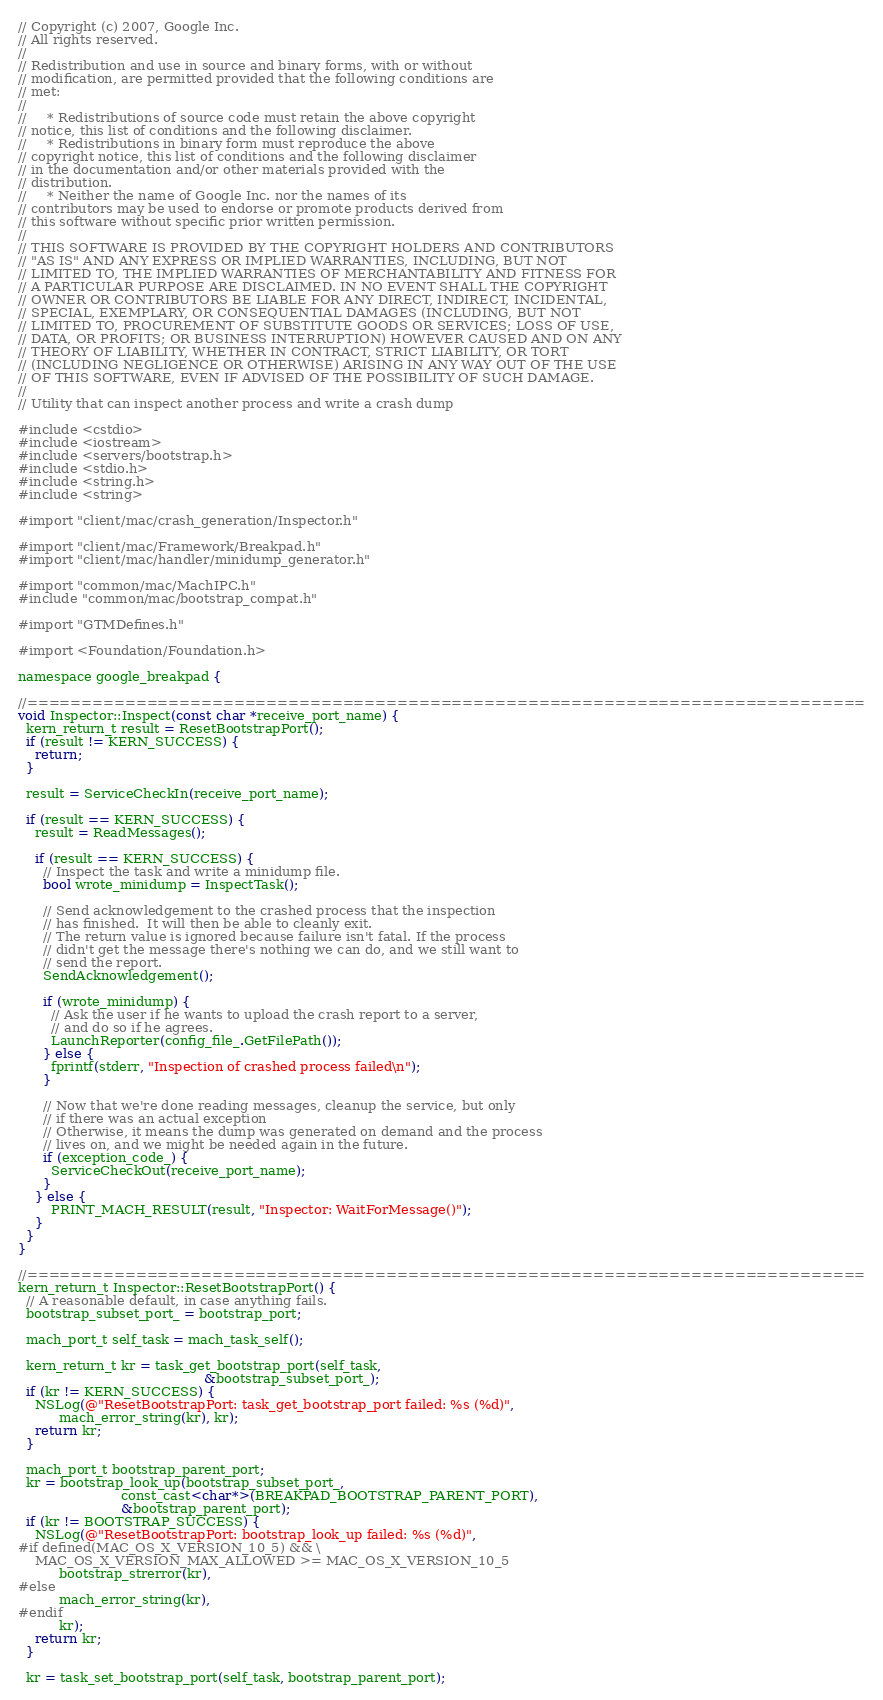<code> <loc_0><loc_0><loc_500><loc_500><_ObjectiveC_>// Copyright (c) 2007, Google Inc.
// All rights reserved.
//
// Redistribution and use in source and binary forms, with or without
// modification, are permitted provided that the following conditions are
// met:
//
//     * Redistributions of source code must retain the above copyright
// notice, this list of conditions and the following disclaimer.
//     * Redistributions in binary form must reproduce the above
// copyright notice, this list of conditions and the following disclaimer
// in the documentation and/or other materials provided with the
// distribution.
//     * Neither the name of Google Inc. nor the names of its
// contributors may be used to endorse or promote products derived from
// this software without specific prior written permission.
//
// THIS SOFTWARE IS PROVIDED BY THE COPYRIGHT HOLDERS AND CONTRIBUTORS
// "AS IS" AND ANY EXPRESS OR IMPLIED WARRANTIES, INCLUDING, BUT NOT
// LIMITED TO, THE IMPLIED WARRANTIES OF MERCHANTABILITY AND FITNESS FOR
// A PARTICULAR PURPOSE ARE DISCLAIMED. IN NO EVENT SHALL THE COPYRIGHT
// OWNER OR CONTRIBUTORS BE LIABLE FOR ANY DIRECT, INDIRECT, INCIDENTAL,
// SPECIAL, EXEMPLARY, OR CONSEQUENTIAL DAMAGES (INCLUDING, BUT NOT
// LIMITED TO, PROCUREMENT OF SUBSTITUTE GOODS OR SERVICES; LOSS OF USE,
// DATA, OR PROFITS; OR BUSINESS INTERRUPTION) HOWEVER CAUSED AND ON ANY
// THEORY OF LIABILITY, WHETHER IN CONTRACT, STRICT LIABILITY, OR TORT
// (INCLUDING NEGLIGENCE OR OTHERWISE) ARISING IN ANY WAY OUT OF THE USE
// OF THIS SOFTWARE, EVEN IF ADVISED OF THE POSSIBILITY OF SUCH DAMAGE.
//
// Utility that can inspect another process and write a crash dump

#include <cstdio>
#include <iostream>
#include <servers/bootstrap.h>
#include <stdio.h>
#include <string.h>
#include <string>

#import "client/mac/crash_generation/Inspector.h"

#import "client/mac/Framework/Breakpad.h"
#import "client/mac/handler/minidump_generator.h"

#import "common/mac/MachIPC.h"
#include "common/mac/bootstrap_compat.h"

#import "GTMDefines.h"

#import <Foundation/Foundation.h>

namespace google_breakpad {

//=============================================================================
void Inspector::Inspect(const char *receive_port_name) {
  kern_return_t result = ResetBootstrapPort();
  if (result != KERN_SUCCESS) {
    return;
  }

  result = ServiceCheckIn(receive_port_name);

  if (result == KERN_SUCCESS) {
    result = ReadMessages();

    if (result == KERN_SUCCESS) {
      // Inspect the task and write a minidump file.
      bool wrote_minidump = InspectTask();

      // Send acknowledgement to the crashed process that the inspection
      // has finished.  It will then be able to cleanly exit.
      // The return value is ignored because failure isn't fatal. If the process
      // didn't get the message there's nothing we can do, and we still want to
      // send the report.
      SendAcknowledgement();

      if (wrote_minidump) {
        // Ask the user if he wants to upload the crash report to a server,
        // and do so if he agrees.
        LaunchReporter(config_file_.GetFilePath());
      } else {
        fprintf(stderr, "Inspection of crashed process failed\n");
      }

      // Now that we're done reading messages, cleanup the service, but only
      // if there was an actual exception
      // Otherwise, it means the dump was generated on demand and the process
      // lives on, and we might be needed again in the future.
      if (exception_code_) {
        ServiceCheckOut(receive_port_name);
      }
    } else {
        PRINT_MACH_RESULT(result, "Inspector: WaitForMessage()");
    }
  }
}

//=============================================================================
kern_return_t Inspector::ResetBootstrapPort() {
  // A reasonable default, in case anything fails.
  bootstrap_subset_port_ = bootstrap_port;

  mach_port_t self_task = mach_task_self();

  kern_return_t kr = task_get_bootstrap_port(self_task,
                                             &bootstrap_subset_port_);
  if (kr != KERN_SUCCESS) {
    NSLog(@"ResetBootstrapPort: task_get_bootstrap_port failed: %s (%d)",
          mach_error_string(kr), kr);
    return kr;
  }

  mach_port_t bootstrap_parent_port;
  kr = bootstrap_look_up(bootstrap_subset_port_,
                         const_cast<char*>(BREAKPAD_BOOTSTRAP_PARENT_PORT),
                         &bootstrap_parent_port);
  if (kr != BOOTSTRAP_SUCCESS) {
    NSLog(@"ResetBootstrapPort: bootstrap_look_up failed: %s (%d)",
#if defined(MAC_OS_X_VERSION_10_5) && \
    MAC_OS_X_VERSION_MAX_ALLOWED >= MAC_OS_X_VERSION_10_5
          bootstrap_strerror(kr),
#else
          mach_error_string(kr),
#endif
          kr);
    return kr;
  }

  kr = task_set_bootstrap_port(self_task, bootstrap_parent_port);</code> 